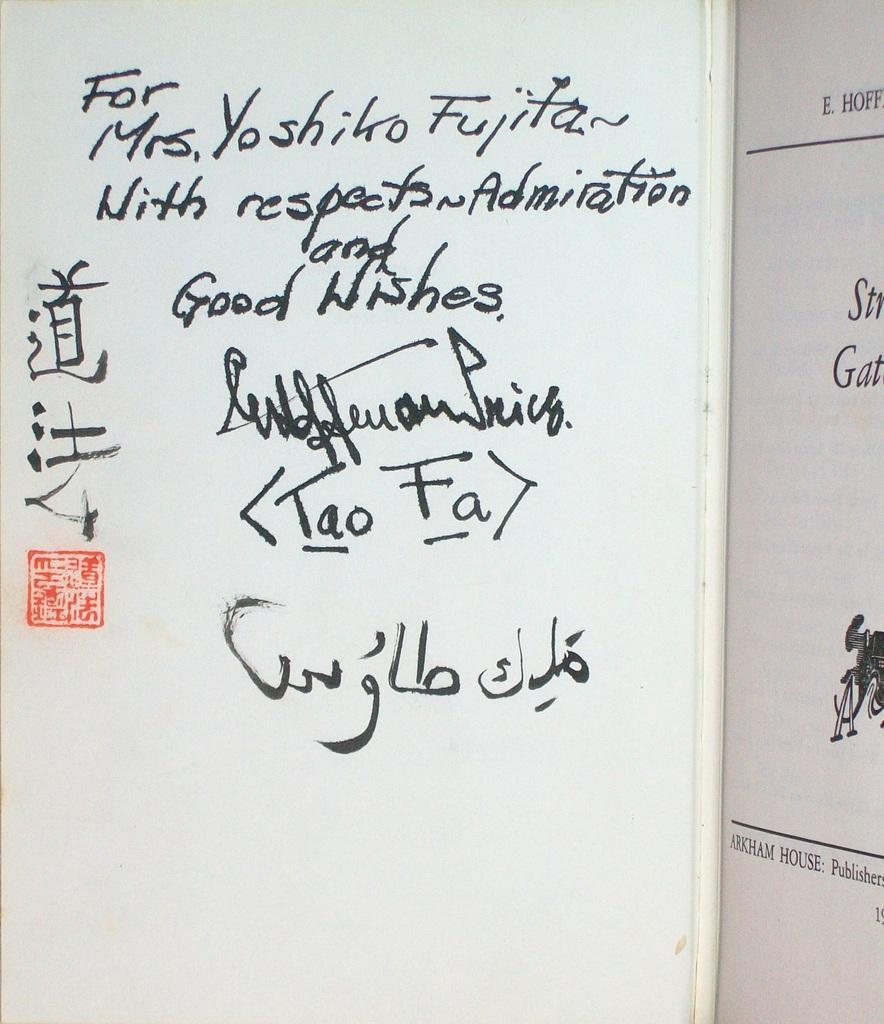What object can be seen in the image? There is a book in the image. What is visible on the book? There is text written on the book. What type of polish is being applied to the book in the image? There is no polish being applied to the book in the image; it only has text written on it. Where is the drawer located in the image? There is no drawer present in the image. 